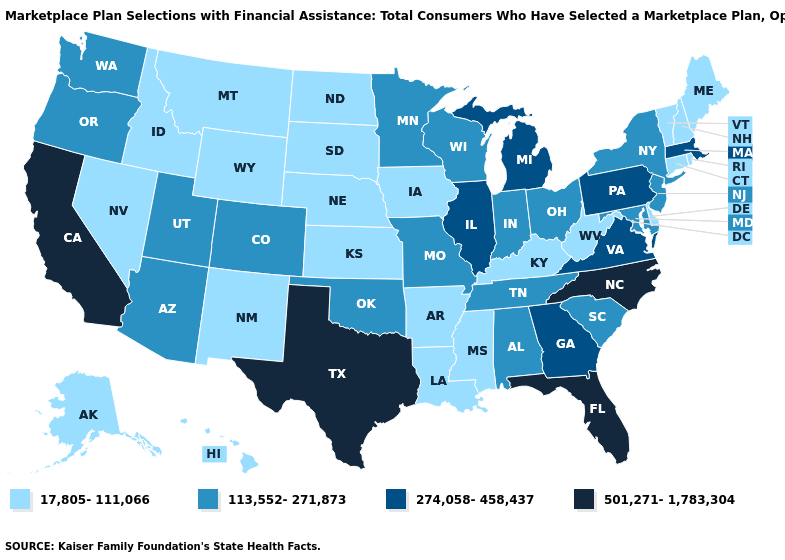What is the value of Minnesota?
Quick response, please. 113,552-271,873. Which states hav the highest value in the MidWest?
Concise answer only. Illinois, Michigan. Among the states that border Texas , which have the lowest value?
Be succinct. Arkansas, Louisiana, New Mexico. What is the value of Connecticut?
Concise answer only. 17,805-111,066. Does Massachusetts have the same value as Illinois?
Short answer required. Yes. What is the value of Wyoming?
Write a very short answer. 17,805-111,066. Does the first symbol in the legend represent the smallest category?
Concise answer only. Yes. What is the value of Missouri?
Keep it brief. 113,552-271,873. What is the value of West Virginia?
Answer briefly. 17,805-111,066. Which states hav the highest value in the Northeast?
Short answer required. Massachusetts, Pennsylvania. Does Indiana have the highest value in the MidWest?
Short answer required. No. Among the states that border Virginia , does Maryland have the highest value?
Concise answer only. No. Name the states that have a value in the range 113,552-271,873?
Concise answer only. Alabama, Arizona, Colorado, Indiana, Maryland, Minnesota, Missouri, New Jersey, New York, Ohio, Oklahoma, Oregon, South Carolina, Tennessee, Utah, Washington, Wisconsin. Does the map have missing data?
Keep it brief. No. Does Pennsylvania have the lowest value in the Northeast?
Short answer required. No. 